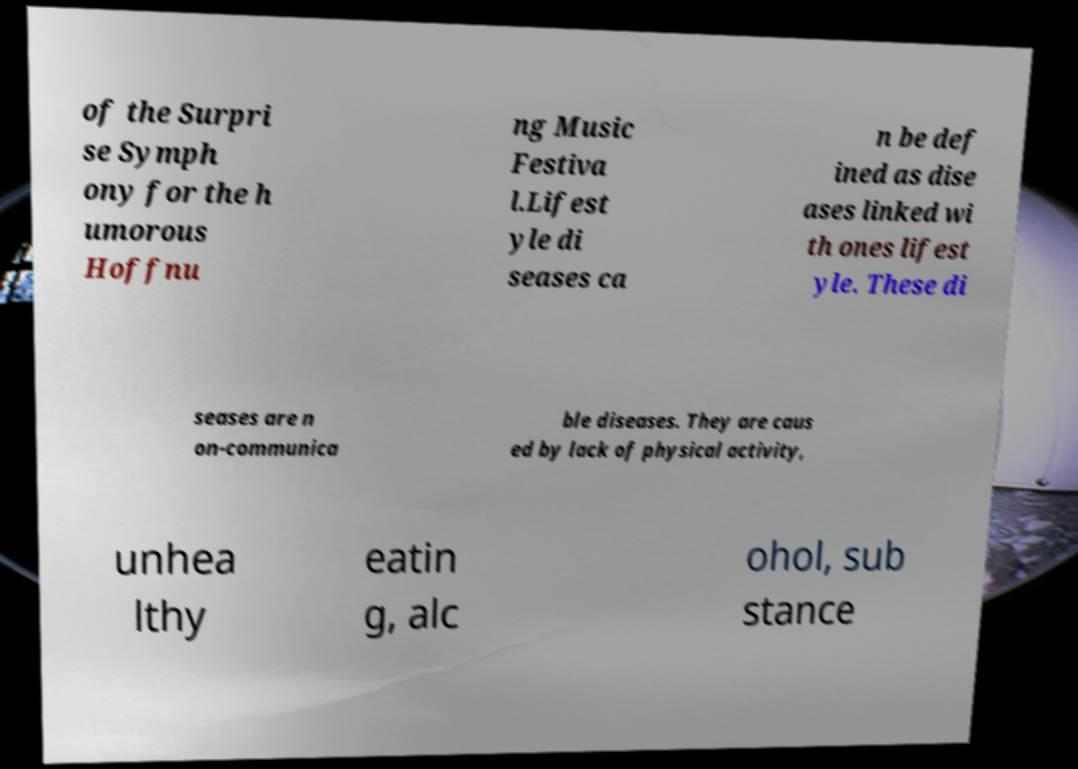Could you extract and type out the text from this image? of the Surpri se Symph ony for the h umorous Hoffnu ng Music Festiva l.Lifest yle di seases ca n be def ined as dise ases linked wi th ones lifest yle. These di seases are n on-communica ble diseases. They are caus ed by lack of physical activity, unhea lthy eatin g, alc ohol, sub stance 